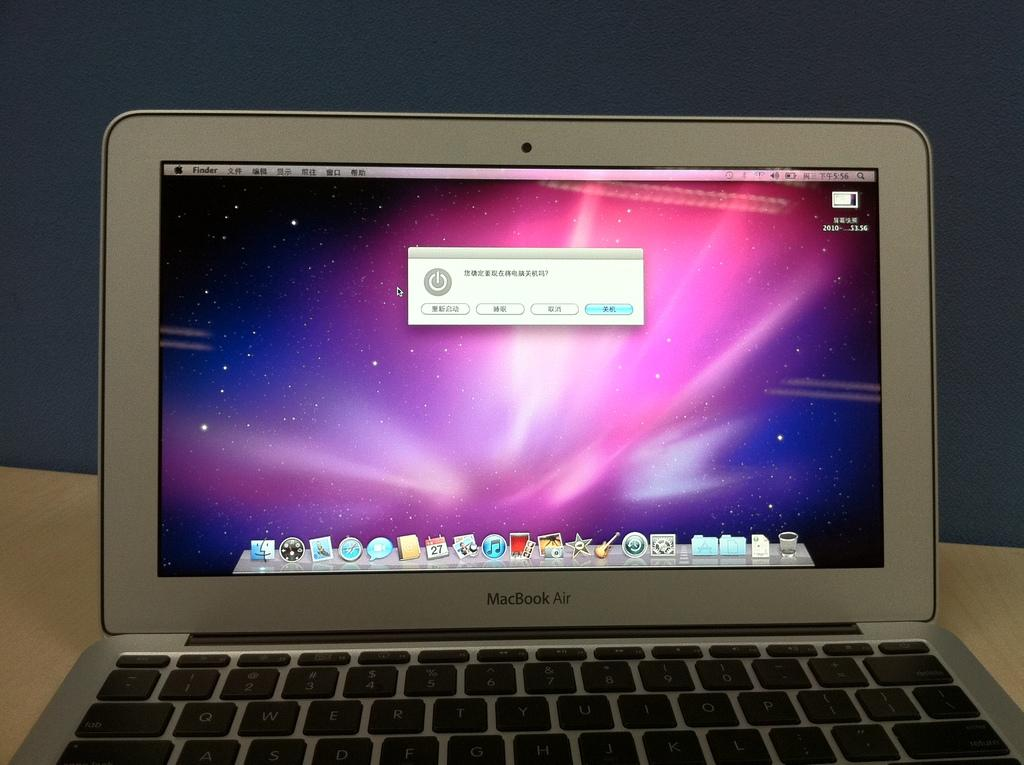Provide a one-sentence caption for the provided image. A MacBook Air computer that is open to the main screen. 